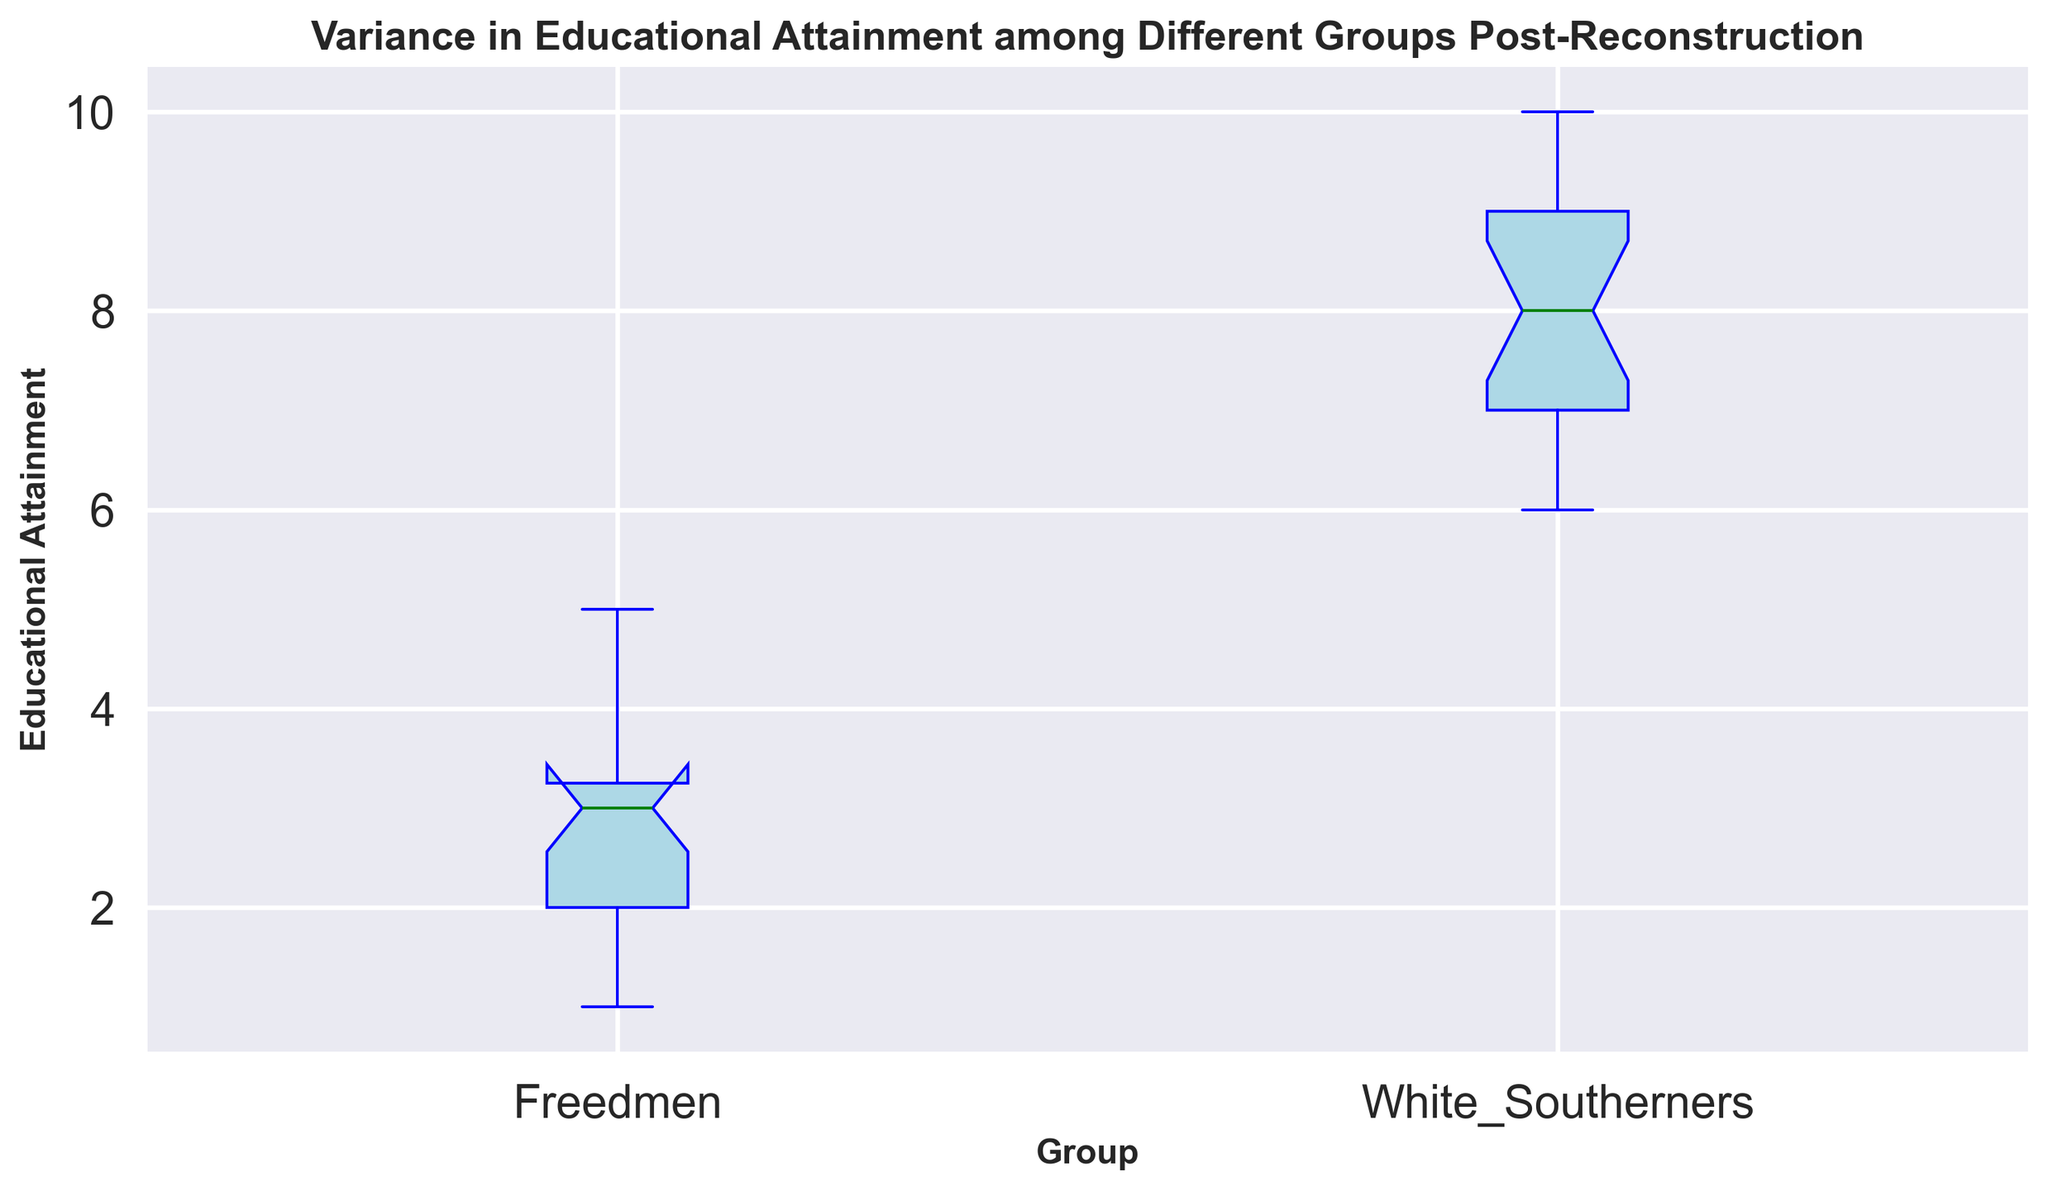What is the median educational attainment for Freedmen? To find the median, look for the middle value in the box plot for the Freedmen group. The median is represented by the line inside the box.
Answer: 3 Which group has a higher average educational attainment, Freedmen or White Southerners? Identify the center line of each box plot: the median (which roughly represents the average). The median for Freedmen is 3, while for White Southerners it is between 7 and 8. This indicates that White Southerners have higher average educational attainment.
Answer: White Southerners What is the range of educational attainment for White Southerners? The range is the difference between the maximum and minimum data points in the box plot. For White Southerners, the maximum is 10 and the minimum is 6. So, range = 10 - 6 = 4.
Answer: 4 Which group has greater variability in educational attainment? Variability can be assessed by looking at the length of the box and whiskers. Freedmen show a larger spread in the box plot compared to White Southerners, indicating higher variability.
Answer: Freedmen What are the interquartile ranges (IQR) for both groups? The IQR is the width of the box in the box plot, representing the middle 50% of the data. For Freedmen, the IQR spans from Q1 (25th percentile) to Q3 (75th percentile), which is likely from 2 to 4. This makes the IQR for Freedmen approximately 2. For White Southerners, the IQR spans from around 6.5 to 8.5, making it approximately 2 as well.
Answer: Freedmen: 2, White Southerners: 2 How do the whisker lengths of both groups compare? The whiskers extend from the box to the smallest and largest values, excluding outliers. Freedmen whiskers are from 1 to 5, and White Southerners whiskers are from 6 to 10. Freedmen whiskers (4 units) are shorter than White Southerners whiskers (4 units), indicating similar lengths.
Answer: Similar lengths Which group has outliers and how are they indicated? Outliers are represented by small circles beyond the whiskers. For Freedmen, there are no outliers as no points lie outside the whiskers.
Answer: No outliers What can be inferred about the educational disparities between the two groups? The box plot shows that Freedmen have lower median educational attainment and a wider variability compared to White Southerners, who have a higher median and tighter range, indicating significant educational disparities post-Reconstruction.
Answer: Significant disparities What is the difference in the upper quartile (Q3) between Freedmen and White Southerners? Q3 is the line at the top of the box. For Freedmen, Q3 is around 4, and for White Southerners, it is around 8.5. The difference is 8.5 - 4 = 4.5.
Answer: 4.5 Which group shows a wider box, and what does that imply? Freedmen show a wider box, indicating a greater interquartile range (IQR) and higher variability in educational attainment compared to White Southerners.
Answer: Freedmen 